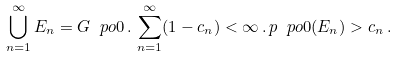<formula> <loc_0><loc_0><loc_500><loc_500>\bigcup _ { n = 1 } ^ { \infty } E _ { n } = G \ p o 0 \, . \, \sum _ { n = 1 } ^ { \infty } ( 1 - c _ { n } ) < \infty \, . \, p \ p o 0 ( E _ { n } ) > c _ { n } \, .</formula> 